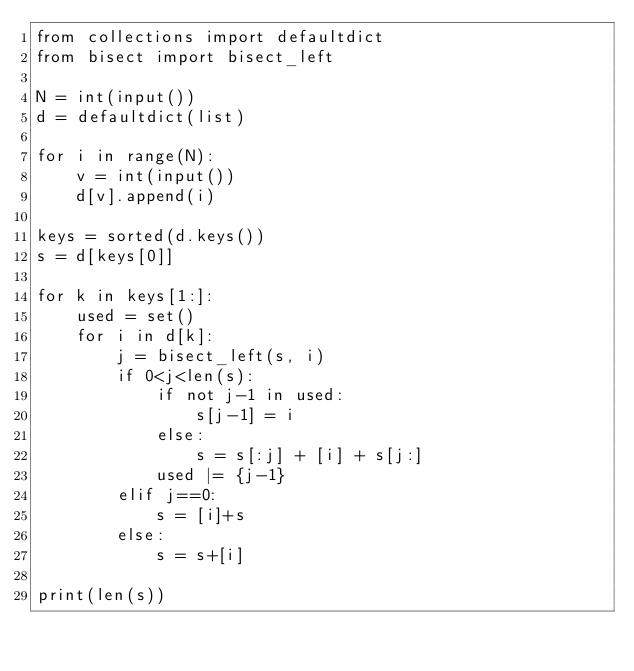Convert code to text. <code><loc_0><loc_0><loc_500><loc_500><_Python_>from collections import defaultdict
from bisect import bisect_left

N = int(input())
d = defaultdict(list)

for i in range(N):
    v = int(input())
    d[v].append(i)

keys = sorted(d.keys())
s = d[keys[0]]

for k in keys[1:]:
    used = set()
    for i in d[k]:
        j = bisect_left(s, i)
        if 0<j<len(s):
            if not j-1 in used:
                s[j-1] = i
            else:
                s = s[:j] + [i] + s[j:]
            used |= {j-1}
        elif j==0:
            s = [i]+s
        else:
            s = s+[i]

print(len(s))</code> 